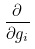<formula> <loc_0><loc_0><loc_500><loc_500>\frac { \partial } { \partial g _ { i } }</formula> 